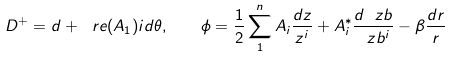Convert formula to latex. <formula><loc_0><loc_0><loc_500><loc_500>D ^ { + } = d + \ r e ( A _ { 1 } ) i d \theta , \quad \phi = \frac { 1 } { 2 } \sum _ { 1 } ^ { n } A _ { i } \frac { d z } { z ^ { i } } + A _ { i } ^ { * } \frac { d \ z b } { \ z b ^ { i } } - \beta \frac { d r } { r }</formula> 